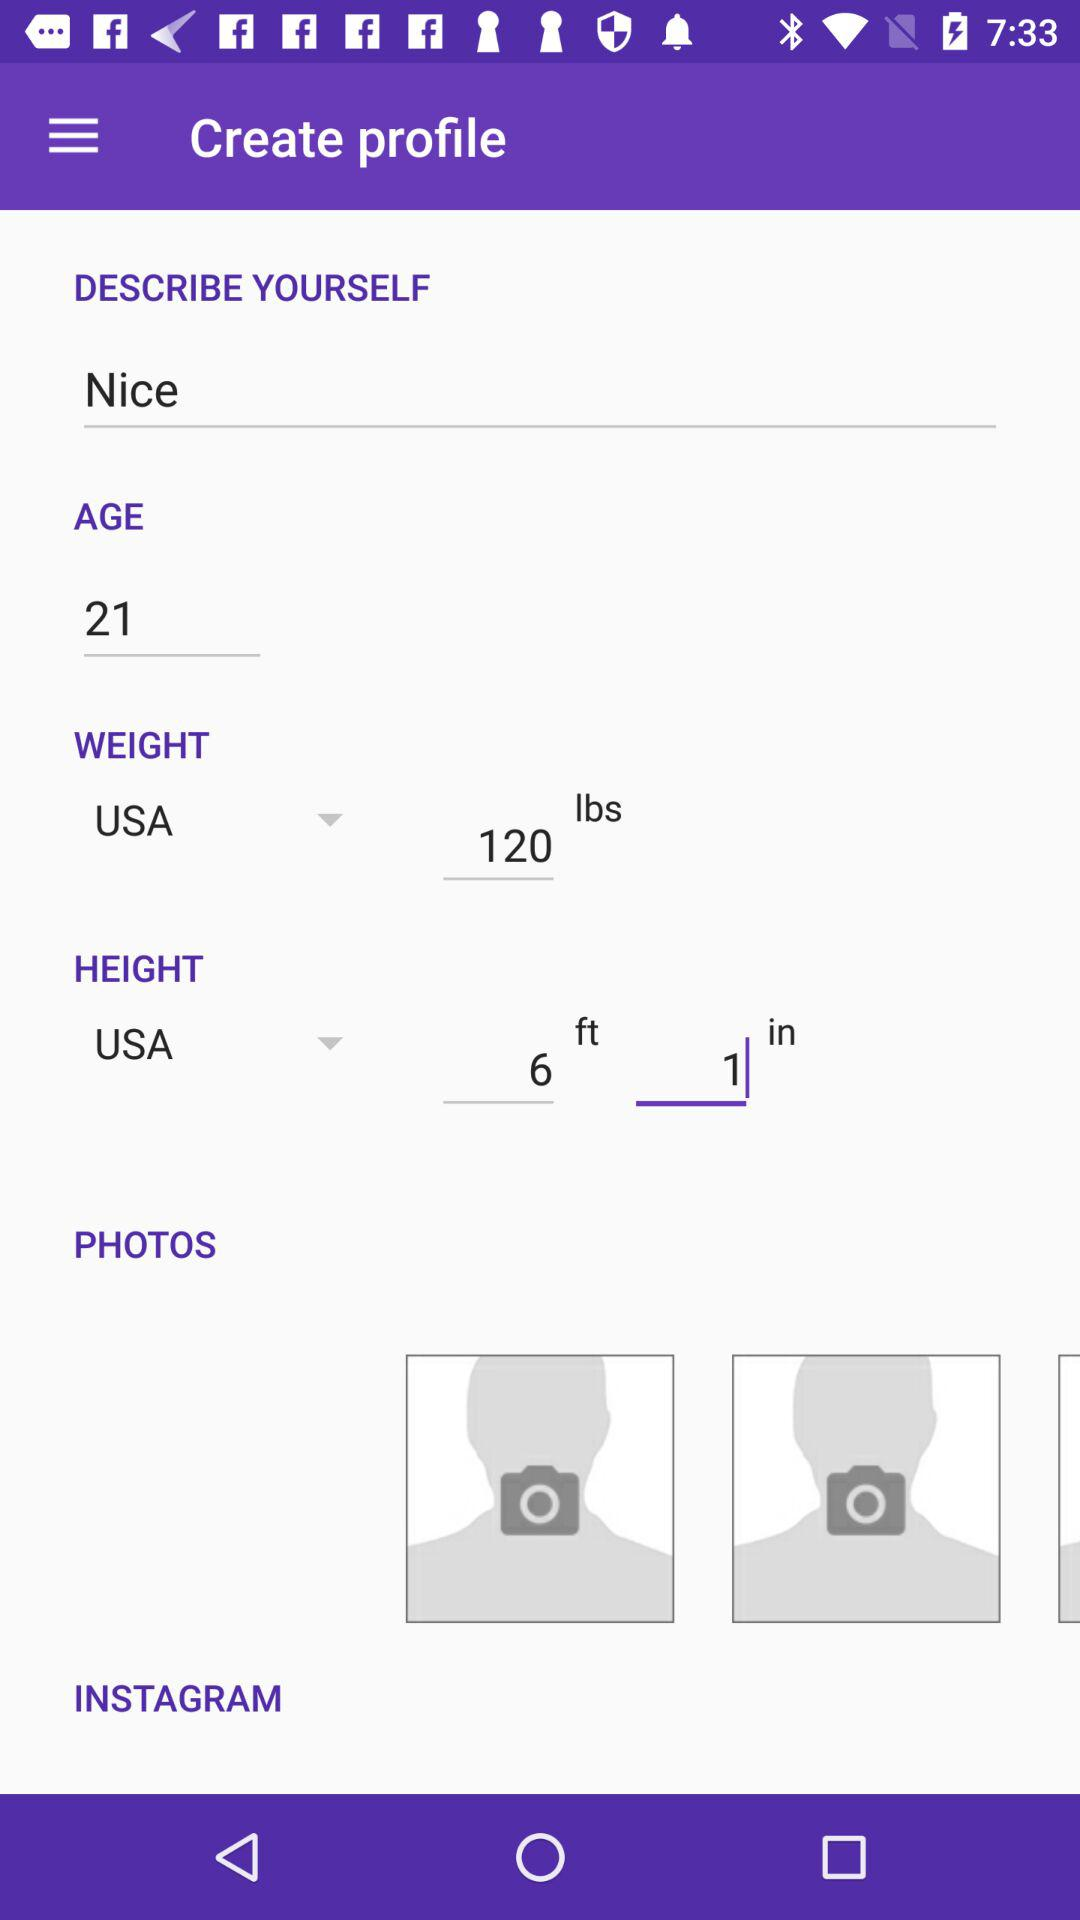What is the height? The height is 6 feet, 1 inch. 